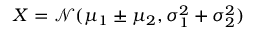<formula> <loc_0><loc_0><loc_500><loc_500>X = \mathcal { N } ( \mu _ { 1 } \pm \mu _ { 2 } , \sigma _ { 1 } ^ { 2 } + \sigma _ { 2 } ^ { 2 } )</formula> 